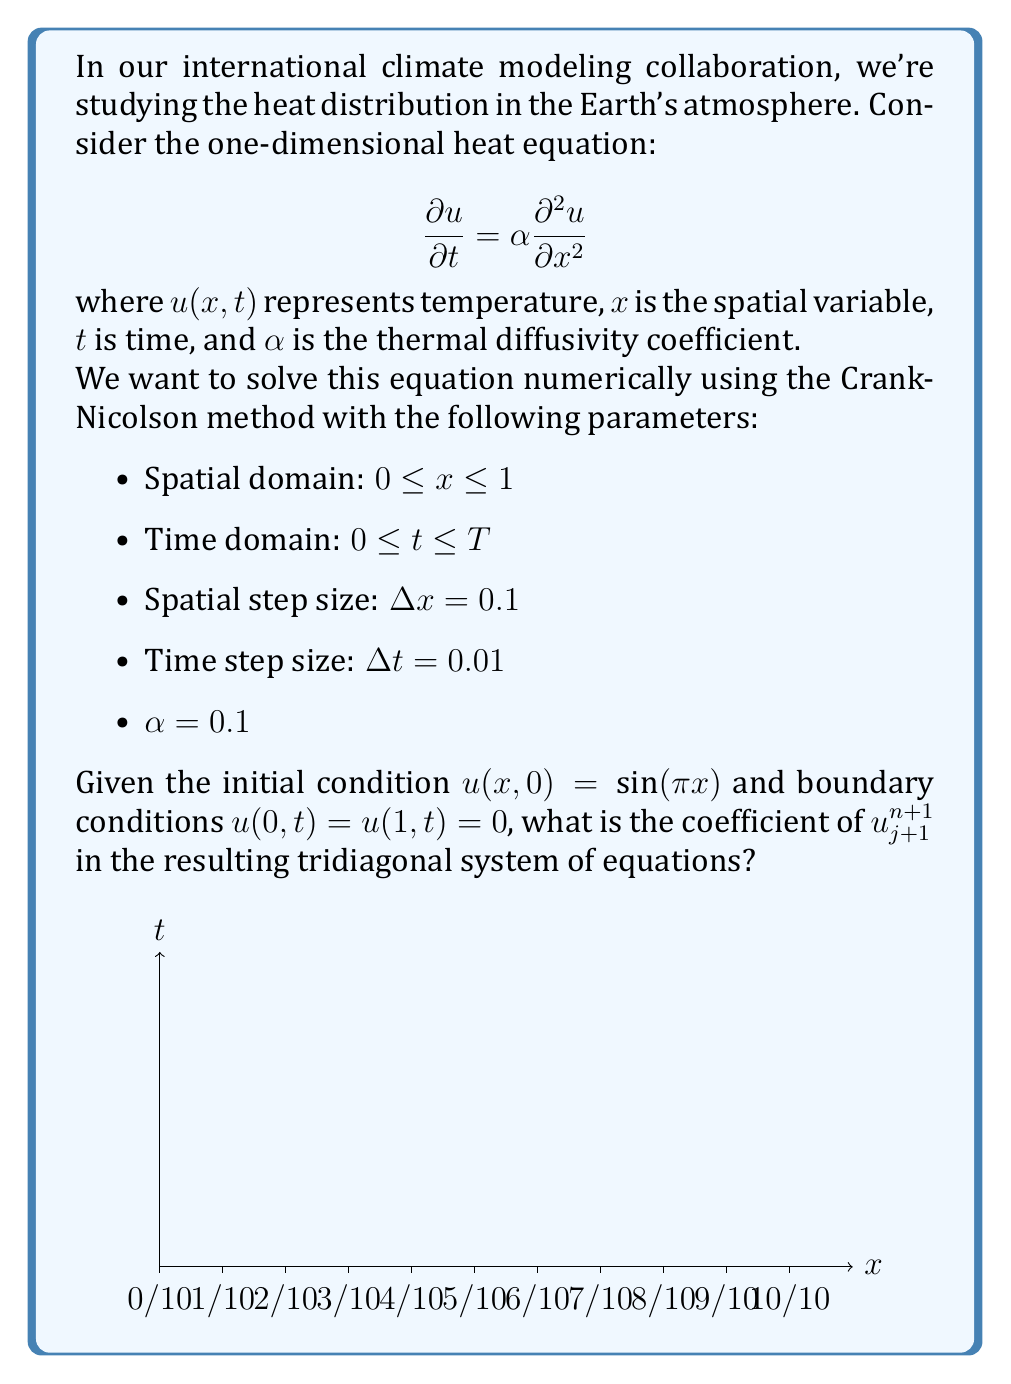Can you solve this math problem? Let's approach this step-by-step:

1) The Crank-Nicolson method is an implicit finite difference method that is second-order accurate in both time and space. It can be written as:

   $$\frac{u_j^{n+1} - u_j^n}{\Delta t} = \frac{\alpha}{2} \left(\frac{u_{j+1}^{n+1} - 2u_j^{n+1} + u_{j-1}^{n+1}}{(\Delta x)^2} + \frac{u_{j+1}^n - 2u_j^n + u_{j-1}^n}{(\Delta x)^2}\right)$$

2) Rearranging this equation:

   $$u_j^{n+1} - u_j^n = \frac{\alpha \Delta t}{2(\Delta x)^2} (u_{j+1}^{n+1} - 2u_j^{n+1} + u_{j-1}^{n+1} + u_{j+1}^n - 2u_j^n + u_{j-1}^n)$$

3) Let's define $r = \frac{\alpha \Delta t}{2(\Delta x)^2}$. With the given parameters:

   $r = \frac{0.1 \cdot 0.01}{2 \cdot (0.1)^2} = 0.05$

4) Substituting and rearranging:

   $-ru_{j-1}^{n+1} + (1+2r)u_j^{n+1} - ru_{j+1}^{n+1} = ru_{j-1}^n + (1-2r)u_j^n + ru_{j+1}^n$

5) In this equation, the coefficient of $u_{j+1}^{n+1}$ is $-r$.

6) Therefore, the coefficient of $u_{j+1}^{n+1}$ in the tridiagonal system is $-r = -0.05$.
Answer: $-0.05$ 